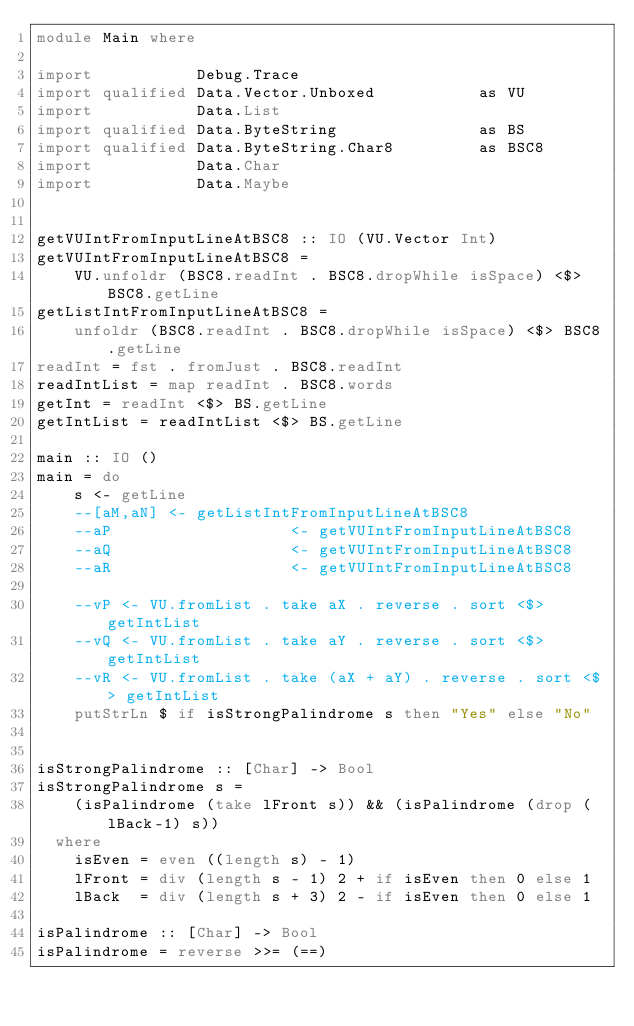<code> <loc_0><loc_0><loc_500><loc_500><_Haskell_>module Main where

import           Debug.Trace
import qualified Data.Vector.Unboxed           as VU
import           Data.List
import qualified Data.ByteString               as BS
import qualified Data.ByteString.Char8         as BSC8
import           Data.Char
import           Data.Maybe


getVUIntFromInputLineAtBSC8 :: IO (VU.Vector Int)
getVUIntFromInputLineAtBSC8 =
    VU.unfoldr (BSC8.readInt . BSC8.dropWhile isSpace) <$> BSC8.getLine
getListIntFromInputLineAtBSC8 =
    unfoldr (BSC8.readInt . BSC8.dropWhile isSpace) <$> BSC8.getLine
readInt = fst . fromJust . BSC8.readInt
readIntList = map readInt . BSC8.words
getInt = readInt <$> BS.getLine
getIntList = readIntList <$> BS.getLine

main :: IO ()
main = do
    s <- getLine
    --[aM,aN] <- getListIntFromInputLineAtBSC8
    --aP                   <- getVUIntFromInputLineAtBSC8
    --aQ                   <- getVUIntFromInputLineAtBSC8
    --aR                   <- getVUIntFromInputLineAtBSC8

    --vP <- VU.fromList . take aX . reverse . sort <$> getIntList
    --vQ <- VU.fromList . take aY . reverse . sort <$> getIntList
    --vR <- VU.fromList . take (aX + aY) . reverse . sort <$> getIntList
    putStrLn $ if isStrongPalindrome s then "Yes" else "No"


isStrongPalindrome :: [Char] -> Bool
isStrongPalindrome s =
    (isPalindrome (take lFront s)) && (isPalindrome (drop (lBack-1) s))
  where
    isEven = even ((length s) - 1)
    lFront = div (length s - 1) 2 + if isEven then 0 else 1
    lBack  = div (length s + 3) 2 - if isEven then 0 else 1

isPalindrome :: [Char] -> Bool
isPalindrome = reverse >>= (==)

</code> 